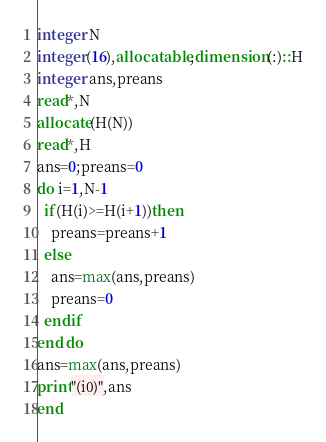Convert code to text. <code><loc_0><loc_0><loc_500><loc_500><_FORTRAN_>integer N
integer(16),allocatable,dimension(:)::H
integer ans,preans
read*,N
allocate(H(N))
read*,H
ans=0;preans=0
do i=1,N-1
  if(H(i)>=H(i+1))then
    preans=preans+1
  else
    ans=max(ans,preans)
    preans=0
  endif
end do
ans=max(ans,preans)
print"(i0)",ans
end</code> 